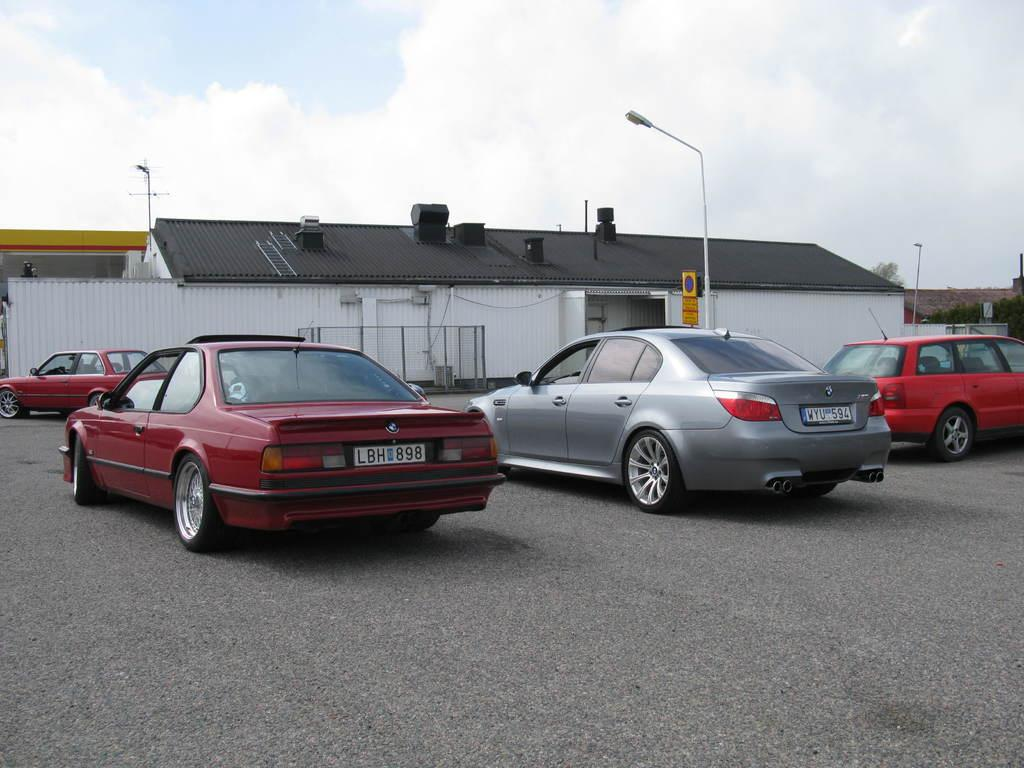What can be seen on the road in the image? There are vehicles on a road in the image. How can the vehicles be distinguished from one another? The vehicles are in different colors. What can be seen in the background of the image? There are poles and buildings in the background. What is the color of the sky in the image? The sky is blue with clouds in the image. What type of war is depicted in the image? There is no war depicted in the image; it features vehicles on a road with buildings and poles in the background. Can you see a scarecrow standing among the vehicles in the image? There is no scarecrow present in the image. 